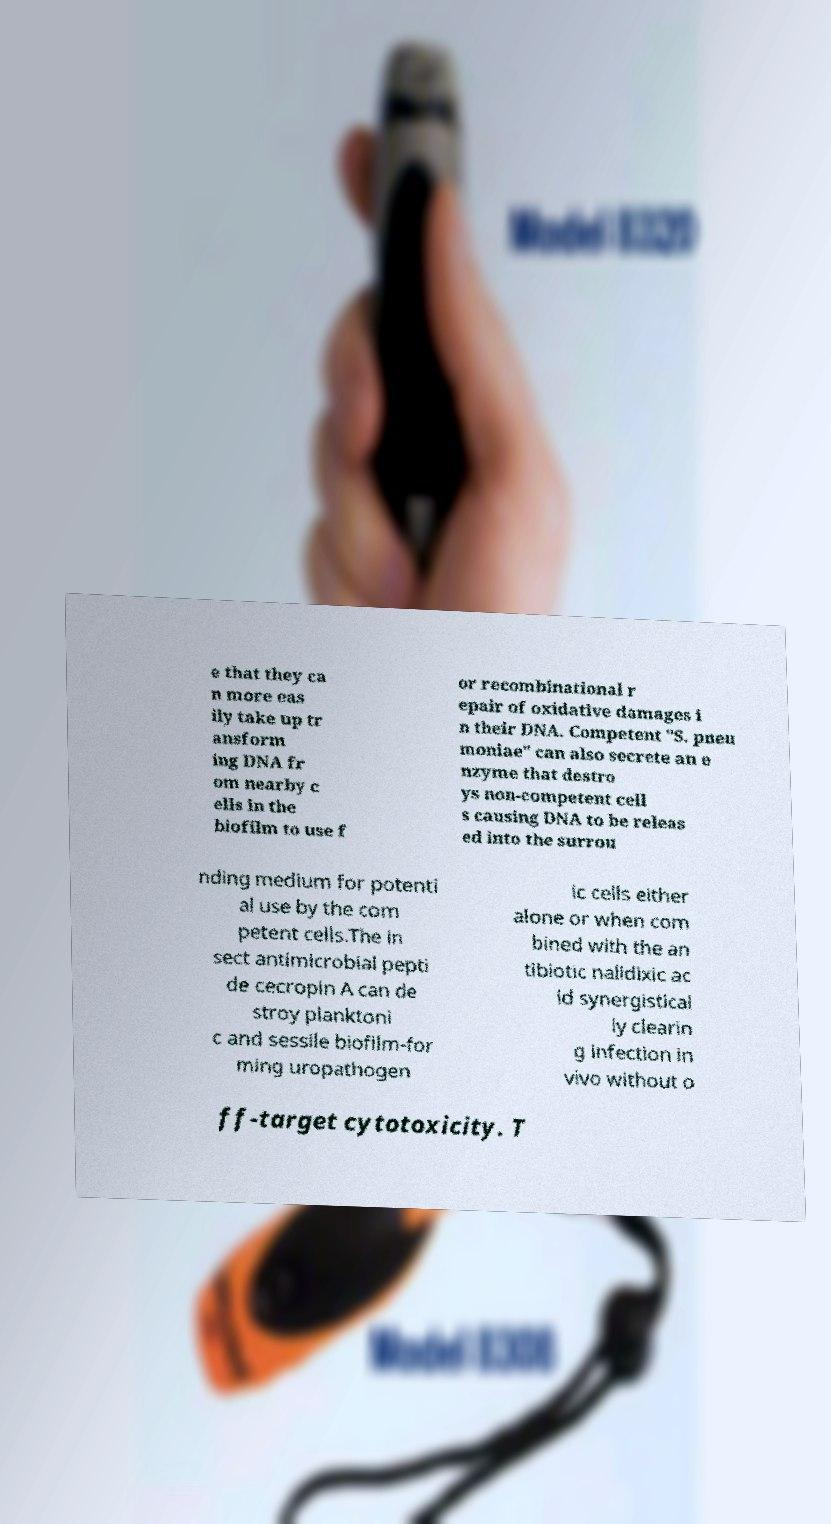There's text embedded in this image that I need extracted. Can you transcribe it verbatim? e that they ca n more eas ily take up tr ansform ing DNA fr om nearby c ells in the biofilm to use f or recombinational r epair of oxidative damages i n their DNA. Competent "S. pneu moniae" can also secrete an e nzyme that destro ys non-competent cell s causing DNA to be releas ed into the surrou nding medium for potenti al use by the com petent cells.The in sect antimicrobial pepti de cecropin A can de stroy planktoni c and sessile biofilm-for ming uropathogen ic cells either alone or when com bined with the an tibiotic nalidixic ac id synergistical ly clearin g infection in vivo without o ff-target cytotoxicity. T 